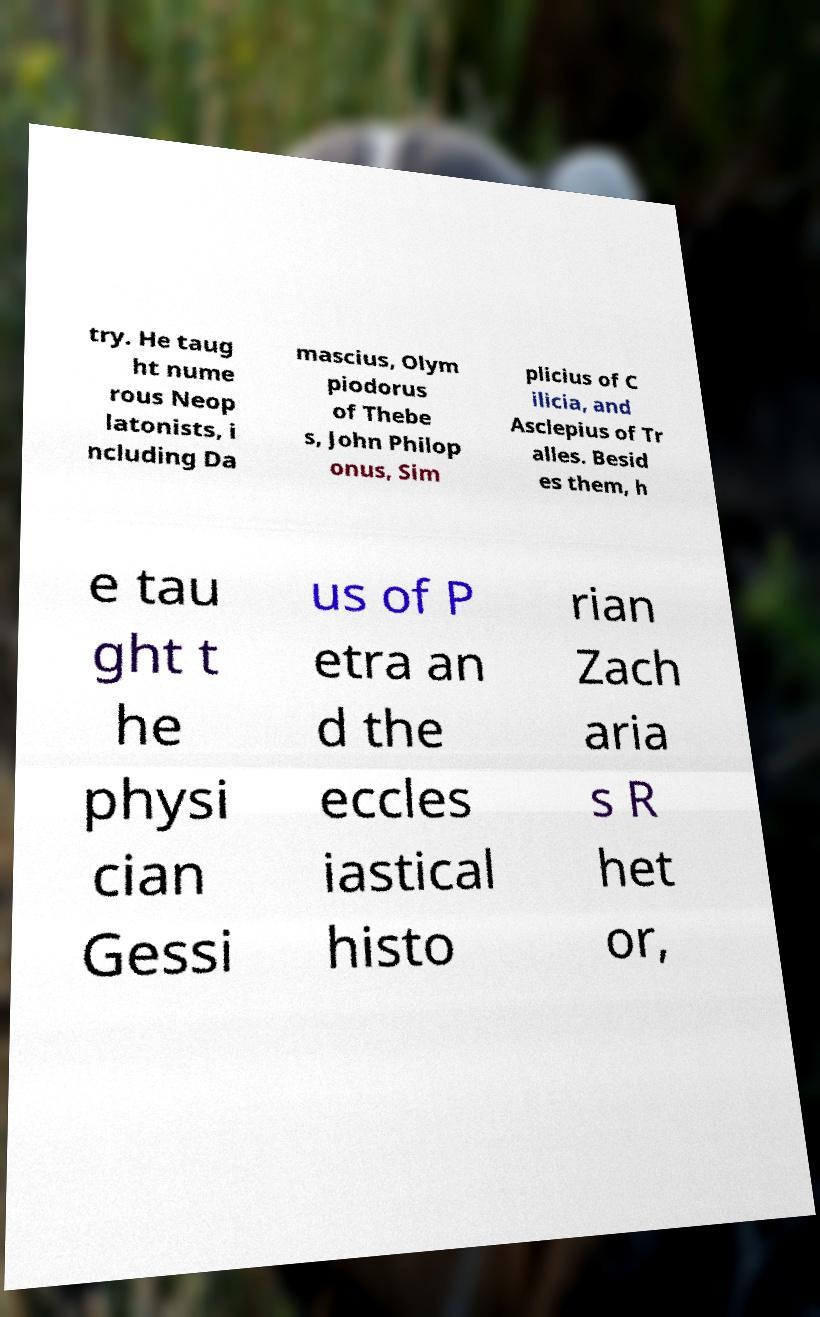There's text embedded in this image that I need extracted. Can you transcribe it verbatim? try. He taug ht nume rous Neop latonists, i ncluding Da mascius, Olym piodorus of Thebe s, John Philop onus, Sim plicius of C ilicia, and Asclepius of Tr alles. Besid es them, h e tau ght t he physi cian Gessi us of P etra an d the eccles iastical histo rian Zach aria s R het or, 